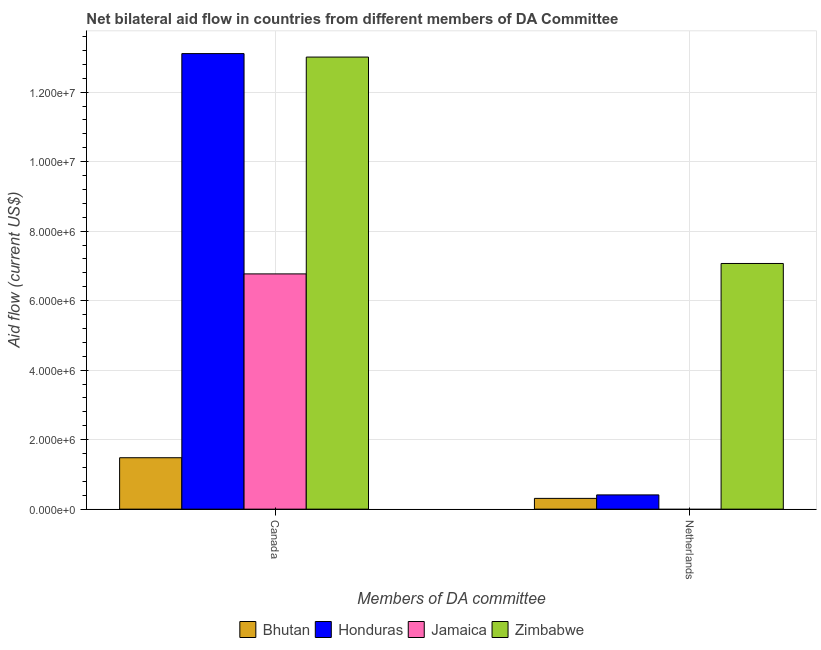How many different coloured bars are there?
Offer a terse response. 4. How many groups of bars are there?
Provide a succinct answer. 2. Are the number of bars per tick equal to the number of legend labels?
Your answer should be compact. No. Are the number of bars on each tick of the X-axis equal?
Provide a short and direct response. No. What is the amount of aid given by netherlands in Jamaica?
Your answer should be very brief. 0. Across all countries, what is the maximum amount of aid given by canada?
Keep it short and to the point. 1.31e+07. Across all countries, what is the minimum amount of aid given by canada?
Your response must be concise. 1.48e+06. In which country was the amount of aid given by canada maximum?
Keep it short and to the point. Honduras. What is the total amount of aid given by canada in the graph?
Your answer should be compact. 3.44e+07. What is the difference between the amount of aid given by canada in Zimbabwe and that in Honduras?
Offer a very short reply. -1.00e+05. What is the difference between the amount of aid given by canada in Honduras and the amount of aid given by netherlands in Jamaica?
Offer a terse response. 1.31e+07. What is the average amount of aid given by netherlands per country?
Keep it short and to the point. 1.95e+06. What is the difference between the amount of aid given by canada and amount of aid given by netherlands in Zimbabwe?
Keep it short and to the point. 5.94e+06. What is the ratio of the amount of aid given by netherlands in Zimbabwe to that in Bhutan?
Offer a very short reply. 22.81. In how many countries, is the amount of aid given by netherlands greater than the average amount of aid given by netherlands taken over all countries?
Provide a short and direct response. 1. Are all the bars in the graph horizontal?
Give a very brief answer. No. What is the difference between two consecutive major ticks on the Y-axis?
Provide a short and direct response. 2.00e+06. Where does the legend appear in the graph?
Make the answer very short. Bottom center. What is the title of the graph?
Make the answer very short. Net bilateral aid flow in countries from different members of DA Committee. What is the label or title of the X-axis?
Make the answer very short. Members of DA committee. What is the Aid flow (current US$) in Bhutan in Canada?
Ensure brevity in your answer.  1.48e+06. What is the Aid flow (current US$) of Honduras in Canada?
Make the answer very short. 1.31e+07. What is the Aid flow (current US$) in Jamaica in Canada?
Your response must be concise. 6.77e+06. What is the Aid flow (current US$) in Zimbabwe in Canada?
Your answer should be very brief. 1.30e+07. What is the Aid flow (current US$) in Bhutan in Netherlands?
Give a very brief answer. 3.10e+05. What is the Aid flow (current US$) of Jamaica in Netherlands?
Provide a short and direct response. 0. What is the Aid flow (current US$) of Zimbabwe in Netherlands?
Your response must be concise. 7.07e+06. Across all Members of DA committee, what is the maximum Aid flow (current US$) of Bhutan?
Provide a succinct answer. 1.48e+06. Across all Members of DA committee, what is the maximum Aid flow (current US$) of Honduras?
Your response must be concise. 1.31e+07. Across all Members of DA committee, what is the maximum Aid flow (current US$) in Jamaica?
Keep it short and to the point. 6.77e+06. Across all Members of DA committee, what is the maximum Aid flow (current US$) of Zimbabwe?
Your response must be concise. 1.30e+07. Across all Members of DA committee, what is the minimum Aid flow (current US$) in Bhutan?
Give a very brief answer. 3.10e+05. Across all Members of DA committee, what is the minimum Aid flow (current US$) in Zimbabwe?
Your response must be concise. 7.07e+06. What is the total Aid flow (current US$) in Bhutan in the graph?
Provide a short and direct response. 1.79e+06. What is the total Aid flow (current US$) of Honduras in the graph?
Provide a succinct answer. 1.35e+07. What is the total Aid flow (current US$) in Jamaica in the graph?
Your answer should be compact. 6.77e+06. What is the total Aid flow (current US$) in Zimbabwe in the graph?
Offer a terse response. 2.01e+07. What is the difference between the Aid flow (current US$) in Bhutan in Canada and that in Netherlands?
Make the answer very short. 1.17e+06. What is the difference between the Aid flow (current US$) in Honduras in Canada and that in Netherlands?
Make the answer very short. 1.27e+07. What is the difference between the Aid flow (current US$) in Zimbabwe in Canada and that in Netherlands?
Keep it short and to the point. 5.94e+06. What is the difference between the Aid flow (current US$) of Bhutan in Canada and the Aid flow (current US$) of Honduras in Netherlands?
Provide a succinct answer. 1.07e+06. What is the difference between the Aid flow (current US$) of Bhutan in Canada and the Aid flow (current US$) of Zimbabwe in Netherlands?
Your answer should be compact. -5.59e+06. What is the difference between the Aid flow (current US$) in Honduras in Canada and the Aid flow (current US$) in Zimbabwe in Netherlands?
Make the answer very short. 6.04e+06. What is the average Aid flow (current US$) of Bhutan per Members of DA committee?
Your answer should be very brief. 8.95e+05. What is the average Aid flow (current US$) in Honduras per Members of DA committee?
Keep it short and to the point. 6.76e+06. What is the average Aid flow (current US$) in Jamaica per Members of DA committee?
Offer a terse response. 3.38e+06. What is the average Aid flow (current US$) in Zimbabwe per Members of DA committee?
Ensure brevity in your answer.  1.00e+07. What is the difference between the Aid flow (current US$) in Bhutan and Aid flow (current US$) in Honduras in Canada?
Your response must be concise. -1.16e+07. What is the difference between the Aid flow (current US$) of Bhutan and Aid flow (current US$) of Jamaica in Canada?
Your answer should be compact. -5.29e+06. What is the difference between the Aid flow (current US$) of Bhutan and Aid flow (current US$) of Zimbabwe in Canada?
Provide a succinct answer. -1.15e+07. What is the difference between the Aid flow (current US$) in Honduras and Aid flow (current US$) in Jamaica in Canada?
Keep it short and to the point. 6.34e+06. What is the difference between the Aid flow (current US$) of Jamaica and Aid flow (current US$) of Zimbabwe in Canada?
Offer a very short reply. -6.24e+06. What is the difference between the Aid flow (current US$) in Bhutan and Aid flow (current US$) in Zimbabwe in Netherlands?
Your response must be concise. -6.76e+06. What is the difference between the Aid flow (current US$) in Honduras and Aid flow (current US$) in Zimbabwe in Netherlands?
Provide a short and direct response. -6.66e+06. What is the ratio of the Aid flow (current US$) in Bhutan in Canada to that in Netherlands?
Ensure brevity in your answer.  4.77. What is the ratio of the Aid flow (current US$) in Honduras in Canada to that in Netherlands?
Offer a terse response. 31.98. What is the ratio of the Aid flow (current US$) in Zimbabwe in Canada to that in Netherlands?
Keep it short and to the point. 1.84. What is the difference between the highest and the second highest Aid flow (current US$) of Bhutan?
Your response must be concise. 1.17e+06. What is the difference between the highest and the second highest Aid flow (current US$) in Honduras?
Your answer should be compact. 1.27e+07. What is the difference between the highest and the second highest Aid flow (current US$) in Zimbabwe?
Provide a succinct answer. 5.94e+06. What is the difference between the highest and the lowest Aid flow (current US$) of Bhutan?
Offer a terse response. 1.17e+06. What is the difference between the highest and the lowest Aid flow (current US$) in Honduras?
Keep it short and to the point. 1.27e+07. What is the difference between the highest and the lowest Aid flow (current US$) in Jamaica?
Provide a short and direct response. 6.77e+06. What is the difference between the highest and the lowest Aid flow (current US$) in Zimbabwe?
Your response must be concise. 5.94e+06. 